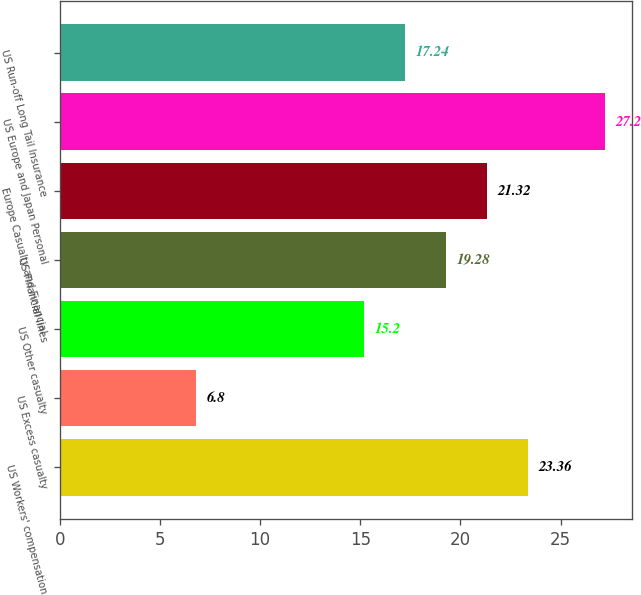<chart> <loc_0><loc_0><loc_500><loc_500><bar_chart><fcel>US Workers' compensation<fcel>US Excess casualty<fcel>US Other casualty<fcel>US Financial lines<fcel>Europe Casualty and Financial<fcel>US Europe and Japan Personal<fcel>US Run-off Long Tail Insurance<nl><fcel>23.36<fcel>6.8<fcel>15.2<fcel>19.28<fcel>21.32<fcel>27.2<fcel>17.24<nl></chart> 